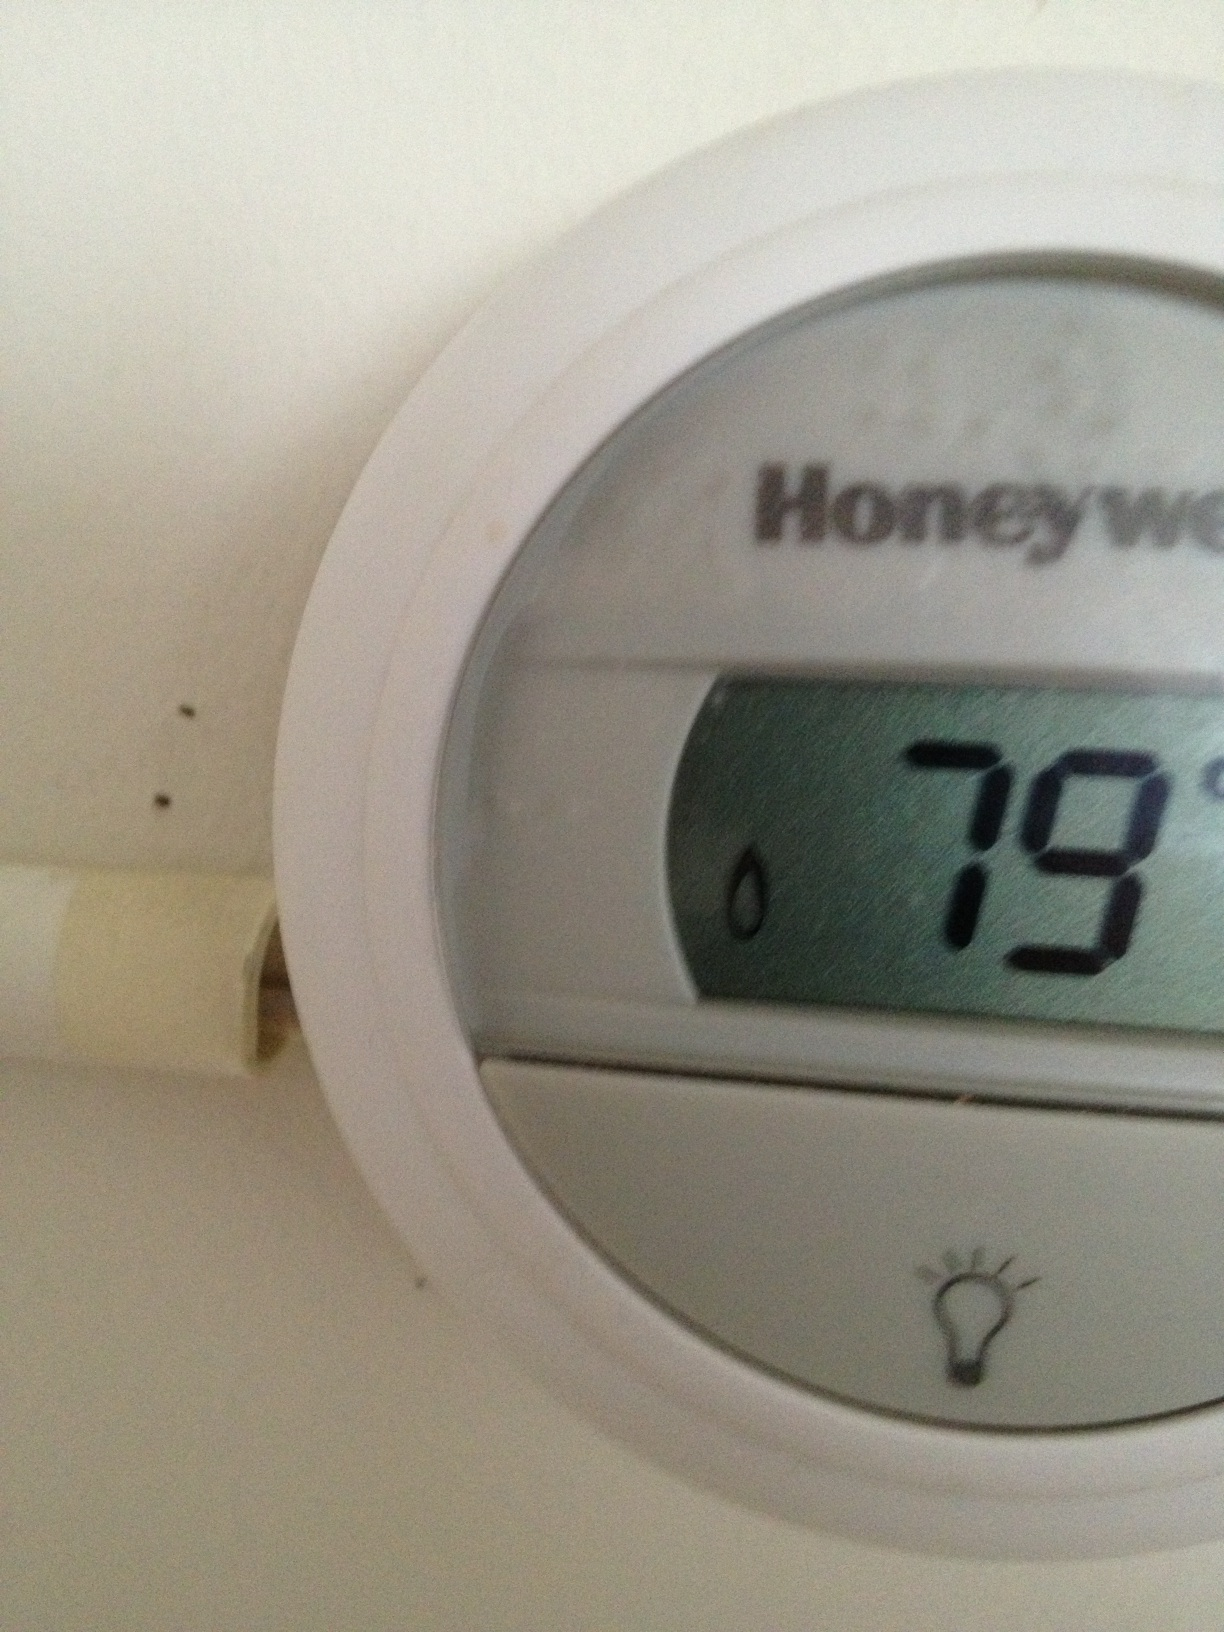What does it say? from Vizwiz 79 